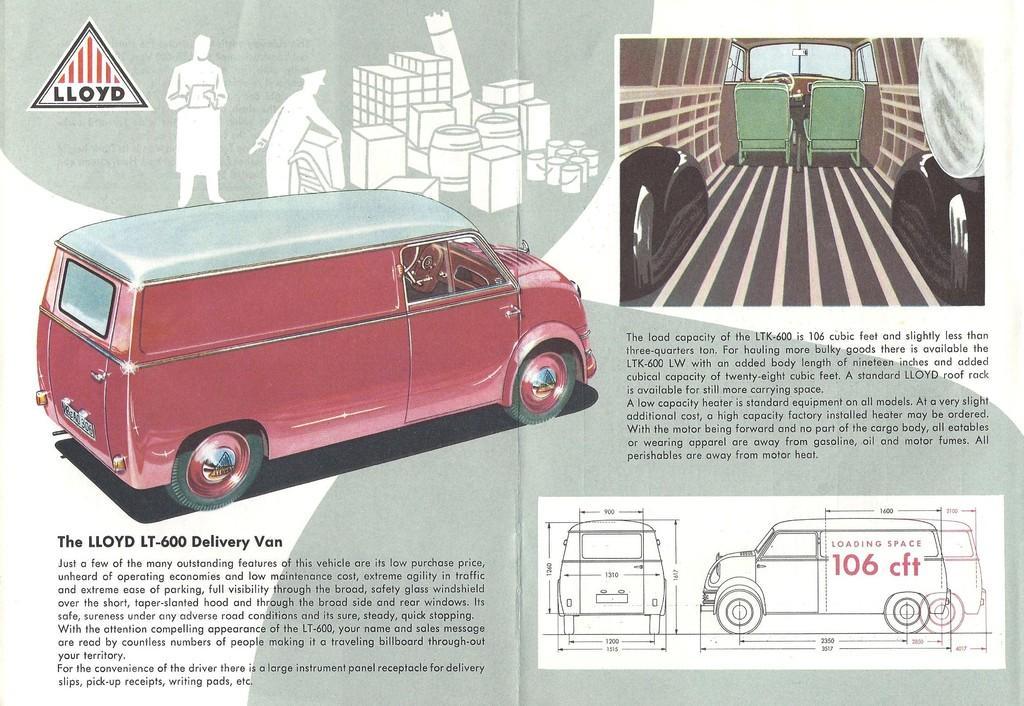Can you describe this image briefly? This is a poster. In this poster, we can see there are paintings of the vehicles, persons and other objects and there are a logo and black color texts. And the background of this poster is white in color. 